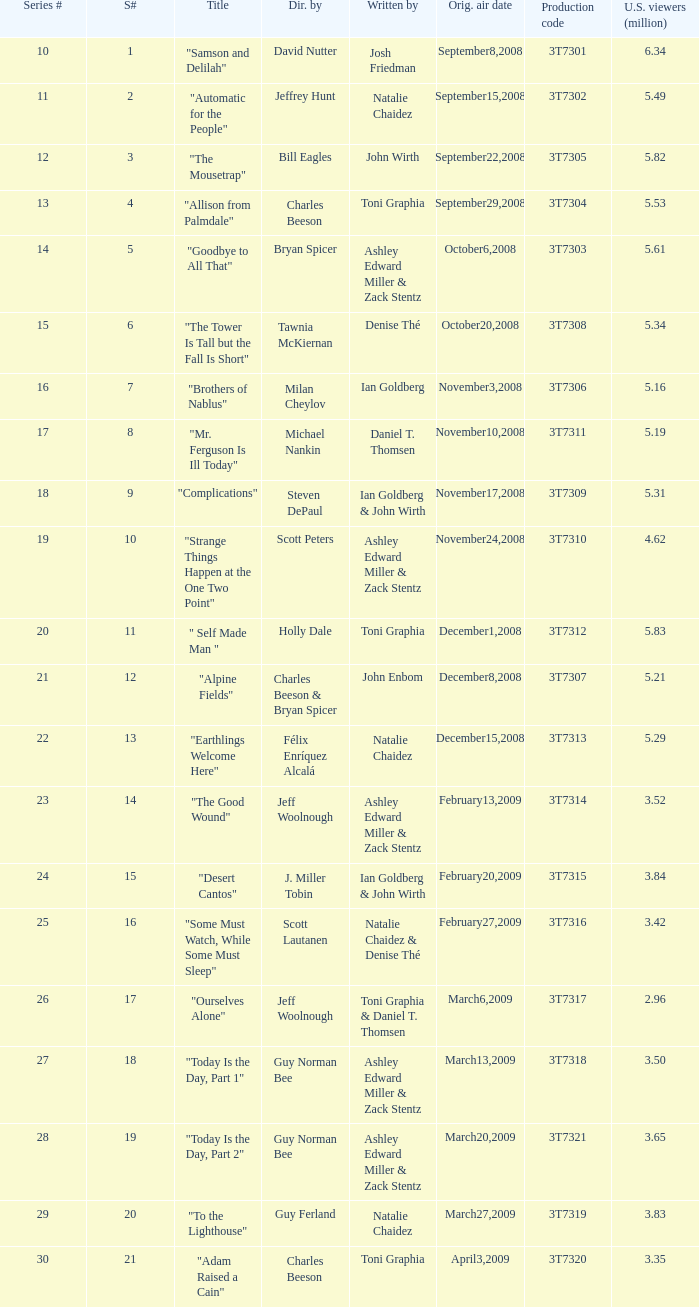Which episode number drew in 3.35 million viewers in the United States? 1.0. 